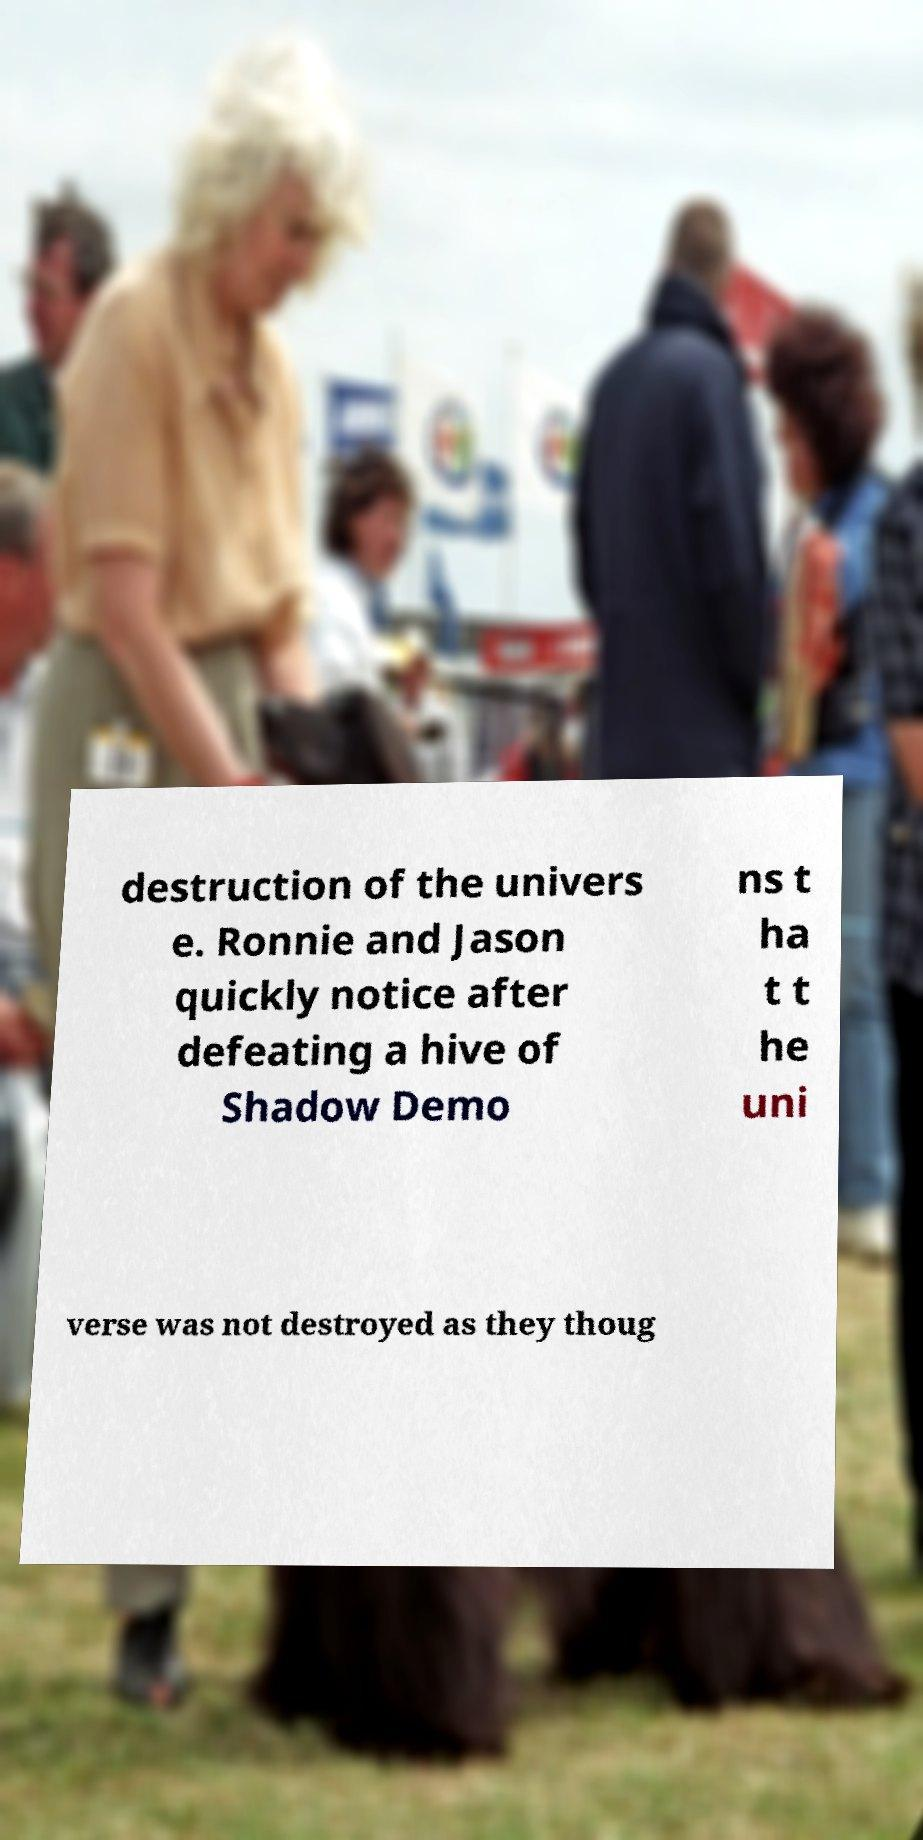I need the written content from this picture converted into text. Can you do that? destruction of the univers e. Ronnie and Jason quickly notice after defeating a hive of Shadow Demo ns t ha t t he uni verse was not destroyed as they thoug 